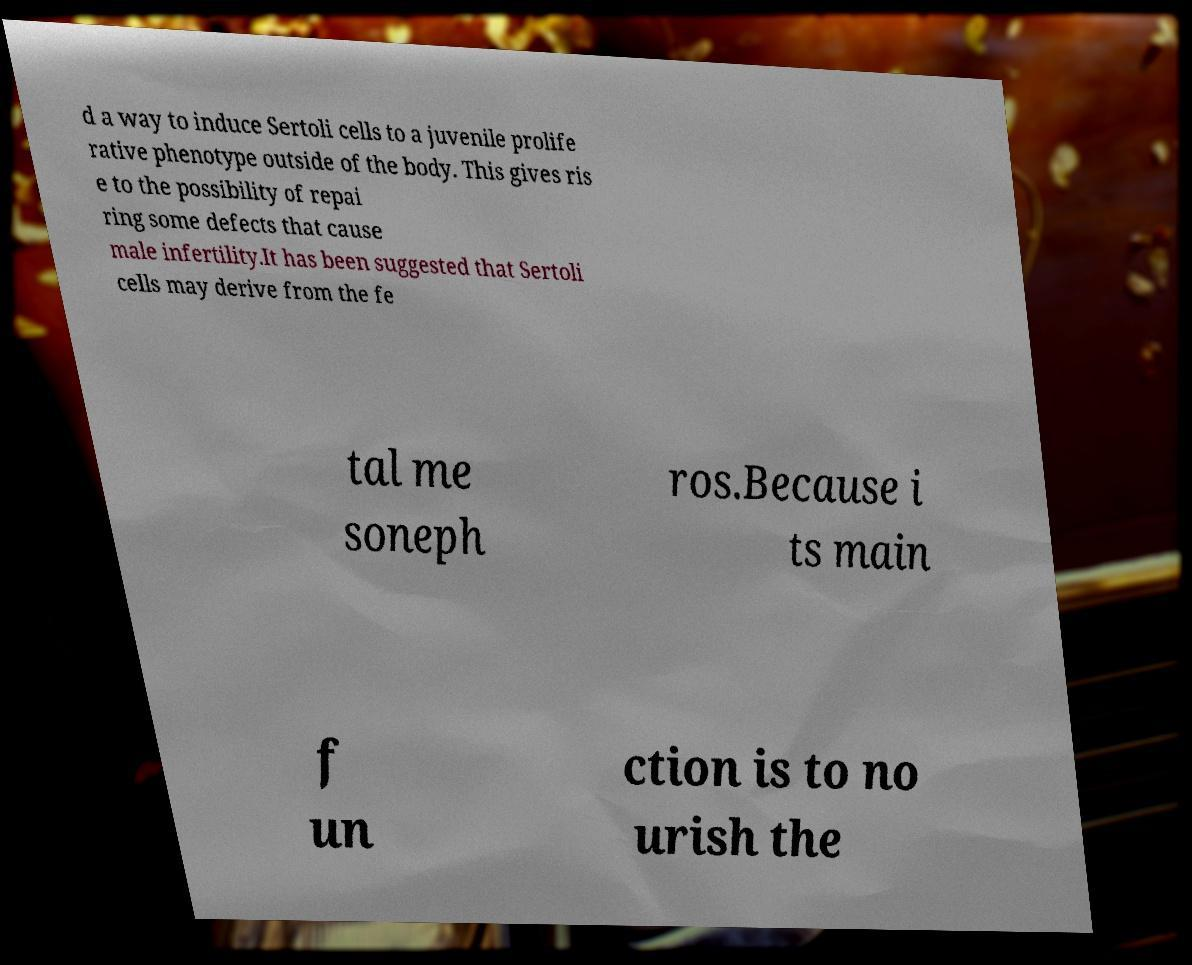Please identify and transcribe the text found in this image. d a way to induce Sertoli cells to a juvenile prolife rative phenotype outside of the body. This gives ris e to the possibility of repai ring some defects that cause male infertility.It has been suggested that Sertoli cells may derive from the fe tal me soneph ros.Because i ts main f un ction is to no urish the 